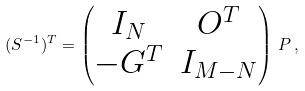<formula> <loc_0><loc_0><loc_500><loc_500>( S ^ { - 1 } ) ^ { T } = \begin{pmatrix} I _ { N } & O ^ { T } \\ - G ^ { T } & I _ { M - N } \end{pmatrix} \, P \, ,</formula> 